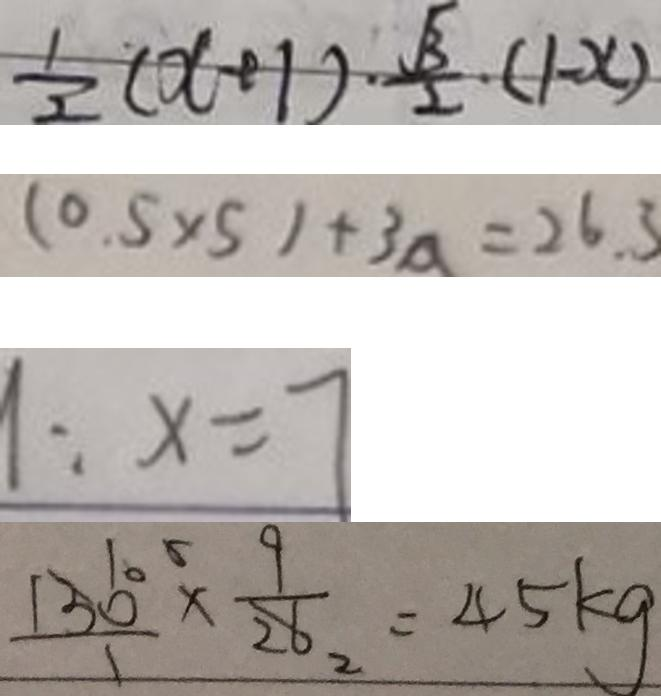Convert formula to latex. <formula><loc_0><loc_0><loc_500><loc_500>\frac { 1 } { 2 } ( x + 1 ) \cdot \frac { \sqrt { 3 } } { 2 } \cdot ( 1 - x ) 
 ( 0 . 5 \times 5 ) + 3 a = 2 6 . 3 
 1 : x = 7 
 \frac { 1 3 6 0 ^ { 5 } } { 1 } \times \frac { 9 } { 2 8 _ { 2 } } = 4 5 k g</formula> 